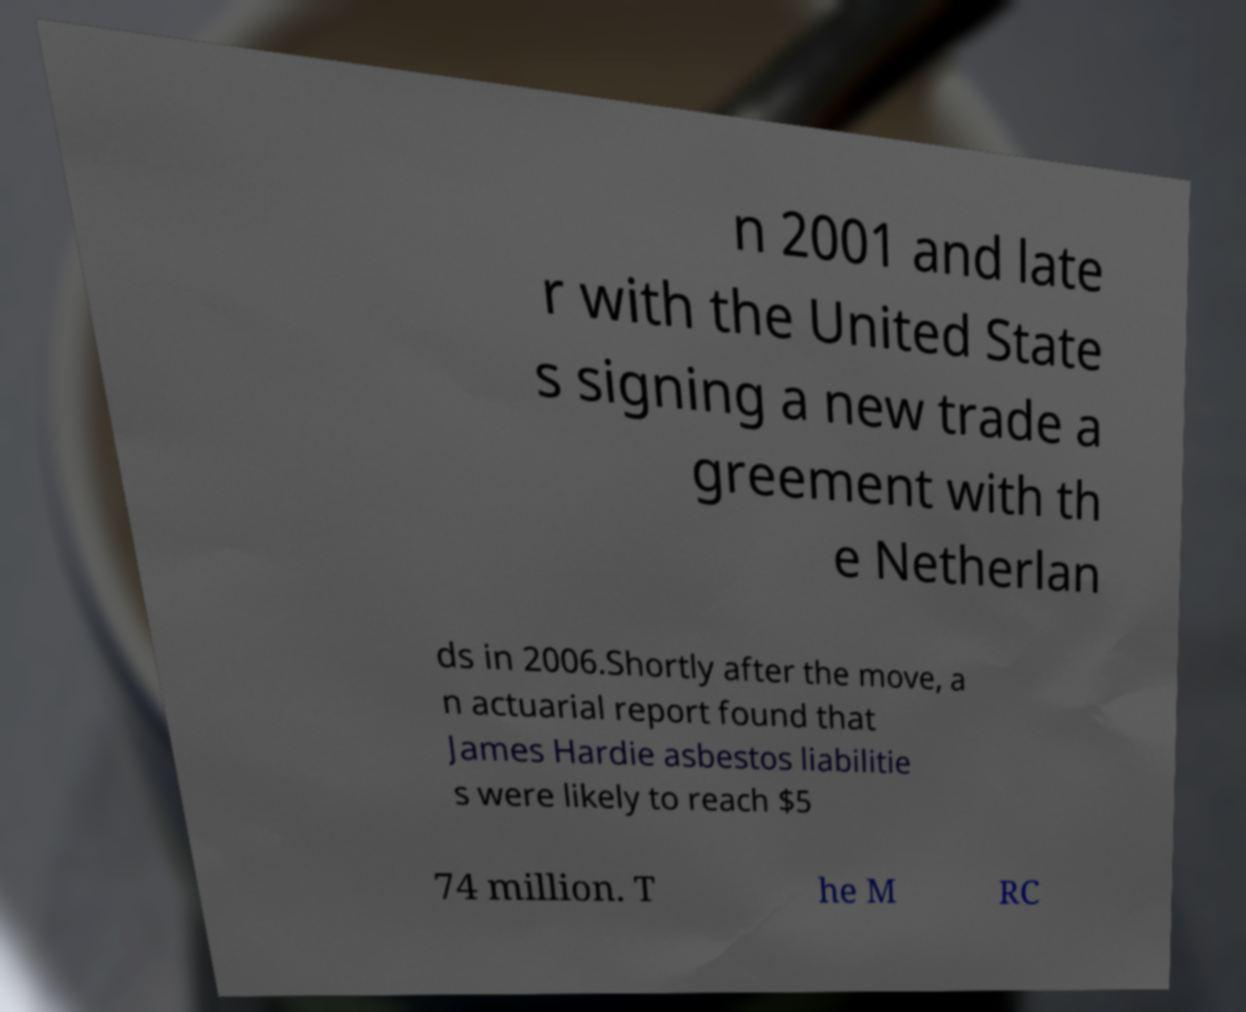Could you assist in decoding the text presented in this image and type it out clearly? n 2001 and late r with the United State s signing a new trade a greement with th e Netherlan ds in 2006.Shortly after the move, a n actuarial report found that James Hardie asbestos liabilitie s were likely to reach $5 74 million. T he M RC 